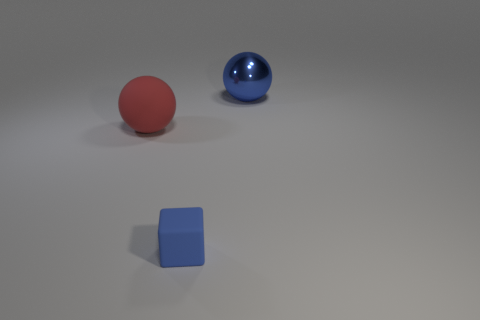Subtract all blue spheres. Subtract all gray cylinders. How many spheres are left? 1 Add 1 small blue blocks. How many objects exist? 4 Subtract all balls. How many objects are left? 1 Add 3 matte balls. How many matte balls exist? 4 Subtract 0 green cylinders. How many objects are left? 3 Subtract all large red rubber spheres. Subtract all big red balls. How many objects are left? 1 Add 3 large metallic things. How many large metallic things are left? 4 